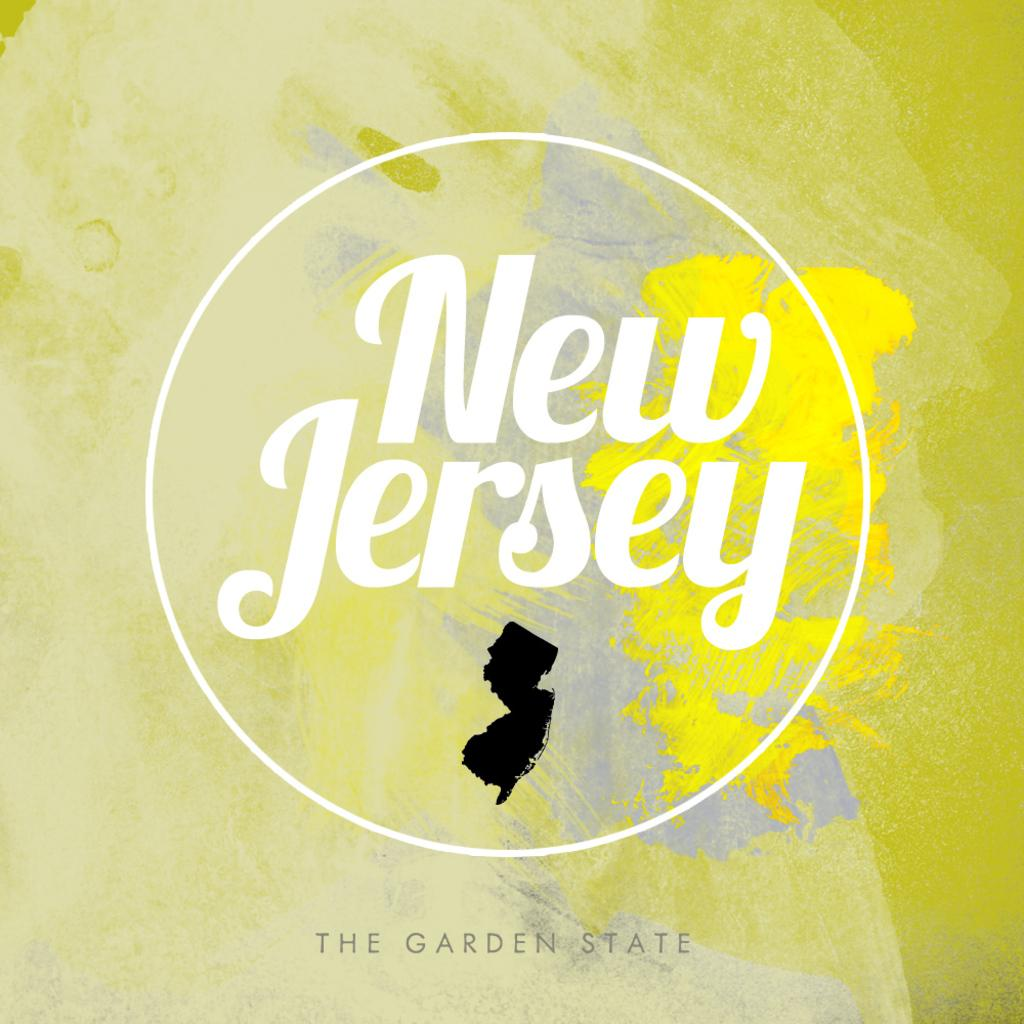Provide a one-sentence caption for the provided image. New Jersey the garden state poster filled with lots of different yellows. 